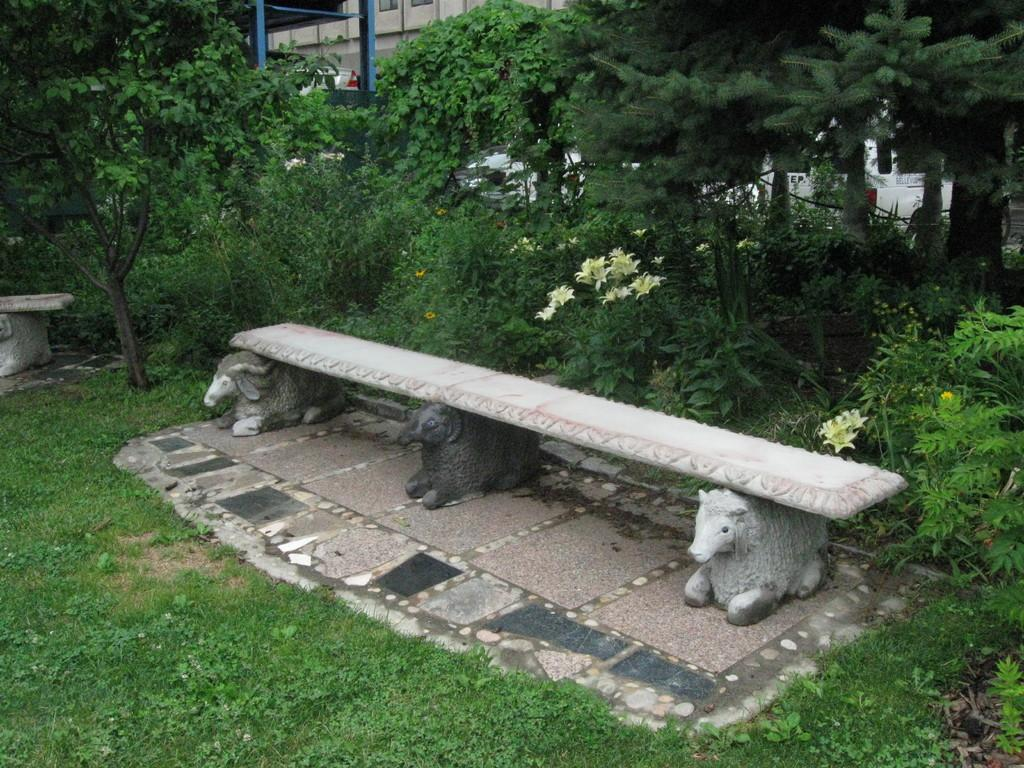What type of seating is visible in the image? There is a bench in the image. What type of vegetation is present in the image? There are plants and grass in the image. What type of structures can be seen in the image? There are buildings in the image. What type of vertical structures are present in the image? There are poles in the image. Where is the honey located in the image? There is no honey present in the image. What type of authority figure can be seen in the image? There is no authority figure present in the image. 